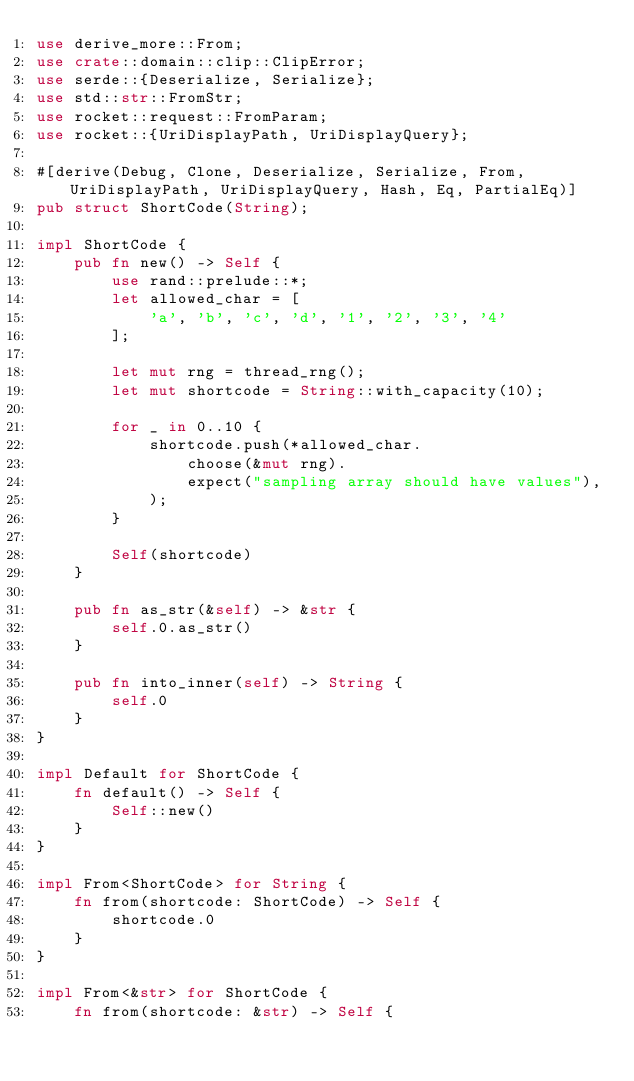Convert code to text. <code><loc_0><loc_0><loc_500><loc_500><_Rust_>use derive_more::From;
use crate::domain::clip::ClipError;
use serde::{Deserialize, Serialize};
use std::str::FromStr;
use rocket::request::FromParam;
use rocket::{UriDisplayPath, UriDisplayQuery};

#[derive(Debug, Clone, Deserialize, Serialize, From, UriDisplayPath, UriDisplayQuery, Hash, Eq, PartialEq)]
pub struct ShortCode(String);

impl ShortCode {
    pub fn new() -> Self {
        use rand::prelude::*;
        let allowed_char = [
            'a', 'b', 'c', 'd', '1', '2', '3', '4'
        ];

        let mut rng = thread_rng();
        let mut shortcode = String::with_capacity(10);

        for _ in 0..10 {
            shortcode.push(*allowed_char.
                choose(&mut rng).
                expect("sampling array should have values"),
            );
        }

        Self(shortcode)
    }

    pub fn as_str(&self) -> &str {
        self.0.as_str()
    }

    pub fn into_inner(self) -> String {
        self.0
    }
}

impl Default for ShortCode {
    fn default() -> Self {
        Self::new()
    }
}

impl From<ShortCode> for String {
    fn from(shortcode: ShortCode) -> Self {
        shortcode.0
    }
}

impl From<&str> for ShortCode {
    fn from(shortcode: &str) -> Self {</code> 